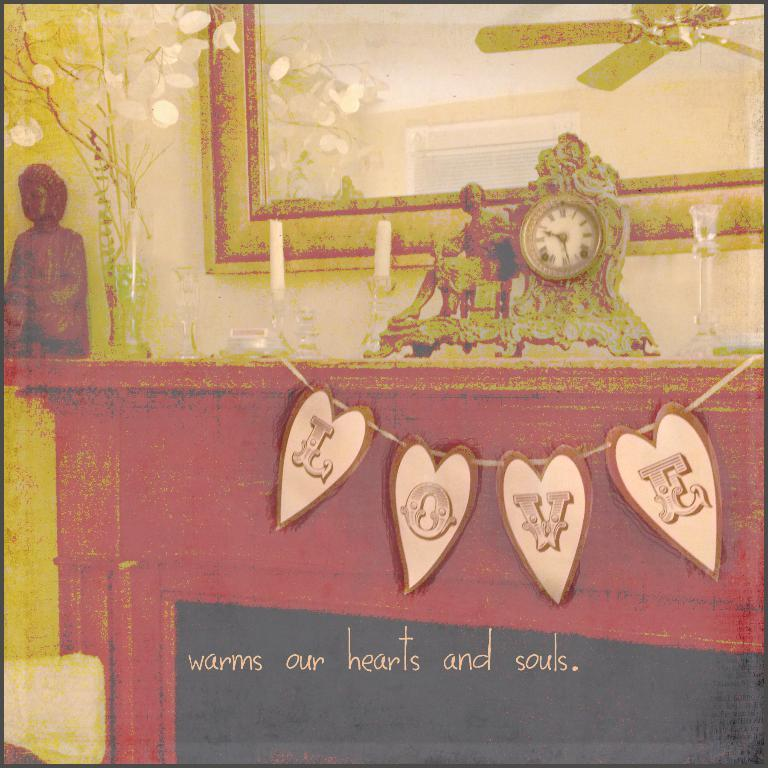<image>
Describe the image concisely. A banner that says LOVE hangs above a fireplace mantel with a tagline that states "warms our hearts and souls." 